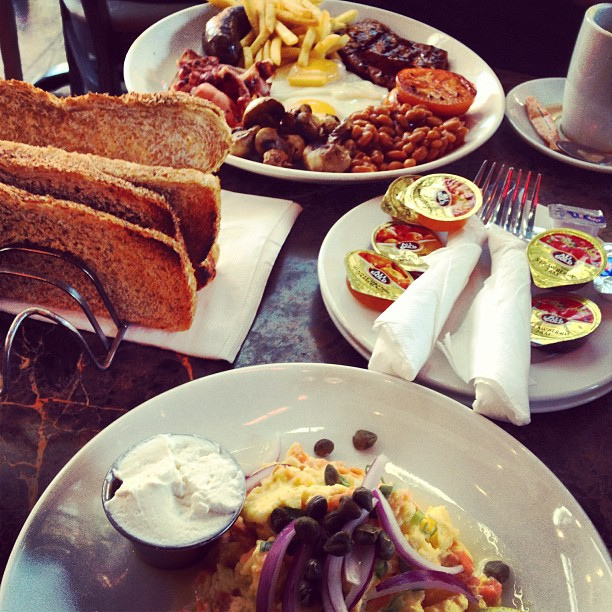What are the different items on the plate in the background with beans and fries? The plate in the background includes beans, fries, grilled tomatoes, mushrooms, sausage, bacon, a sunny-side-up egg, and a piece of steak. 